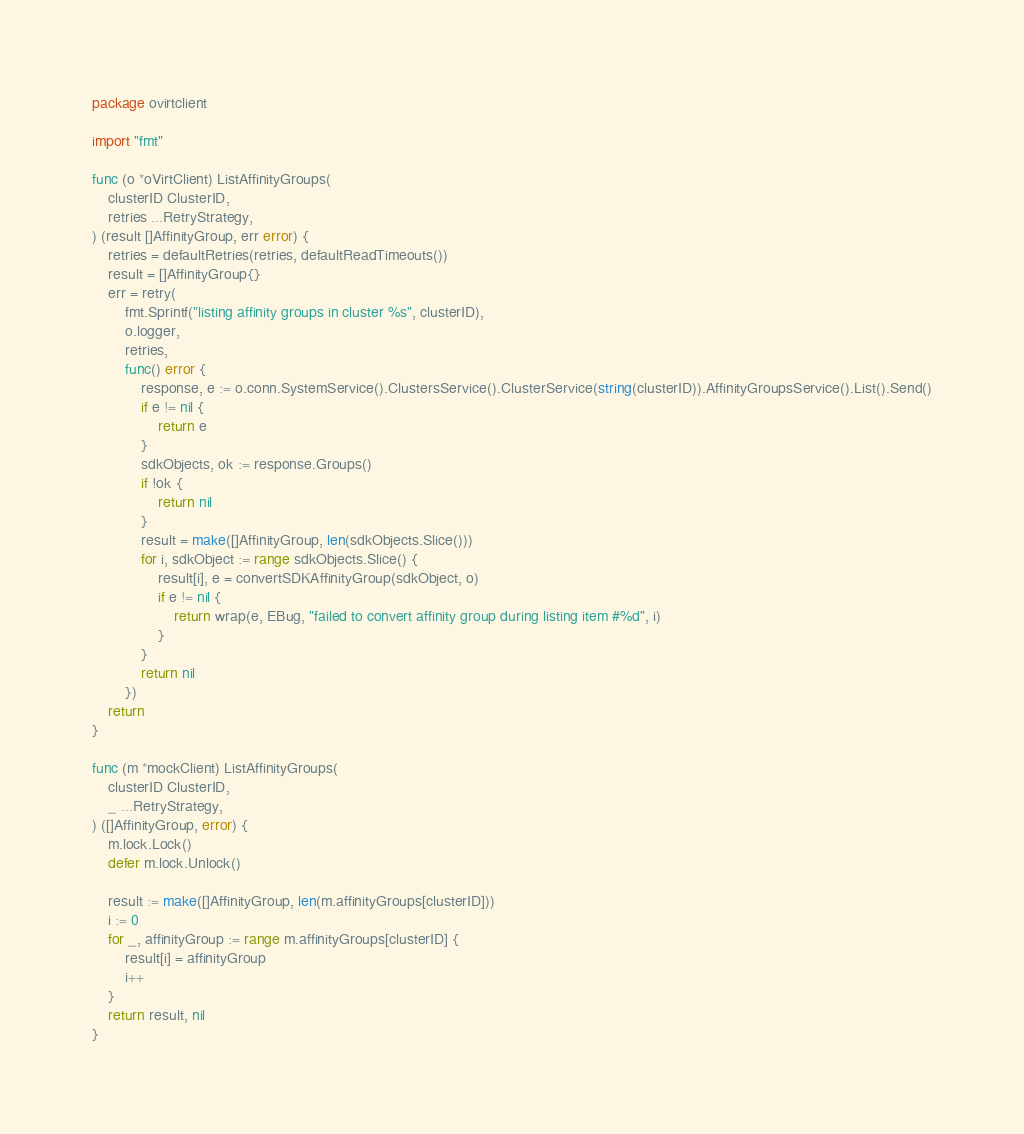<code> <loc_0><loc_0><loc_500><loc_500><_Go_>package ovirtclient

import "fmt"

func (o *oVirtClient) ListAffinityGroups(
	clusterID ClusterID,
	retries ...RetryStrategy,
) (result []AffinityGroup, err error) {
	retries = defaultRetries(retries, defaultReadTimeouts())
	result = []AffinityGroup{}
	err = retry(
		fmt.Sprintf("listing affinity groups in cluster %s", clusterID),
		o.logger,
		retries,
		func() error {
			response, e := o.conn.SystemService().ClustersService().ClusterService(string(clusterID)).AffinityGroupsService().List().Send()
			if e != nil {
				return e
			}
			sdkObjects, ok := response.Groups()
			if !ok {
				return nil
			}
			result = make([]AffinityGroup, len(sdkObjects.Slice()))
			for i, sdkObject := range sdkObjects.Slice() {
				result[i], e = convertSDKAffinityGroup(sdkObject, o)
				if e != nil {
					return wrap(e, EBug, "failed to convert affinity group during listing item #%d", i)
				}
			}
			return nil
		})
	return
}

func (m *mockClient) ListAffinityGroups(
	clusterID ClusterID,
	_ ...RetryStrategy,
) ([]AffinityGroup, error) {
	m.lock.Lock()
	defer m.lock.Unlock()

	result := make([]AffinityGroup, len(m.affinityGroups[clusterID]))
	i := 0
	for _, affinityGroup := range m.affinityGroups[clusterID] {
		result[i] = affinityGroup
		i++
	}
	return result, nil
}
</code> 